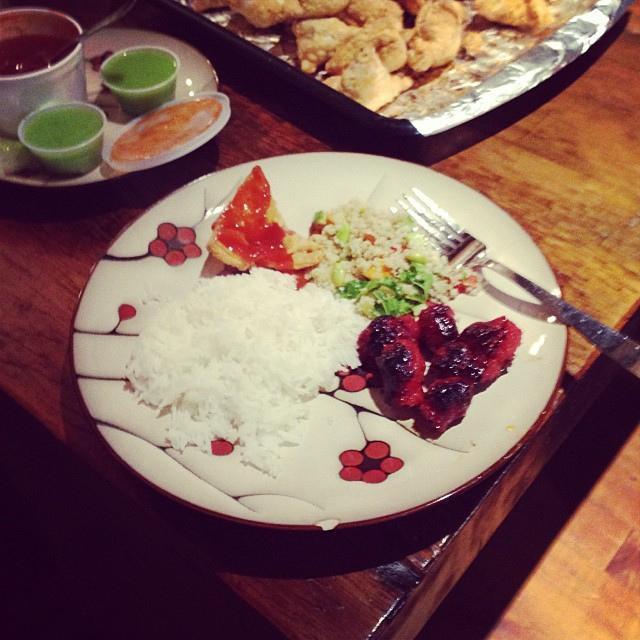How many of the ingredients on the dish were cooked by steaming them?
Pick the correct solution from the four options below to address the question.
Options: One, three, two, four. One. 